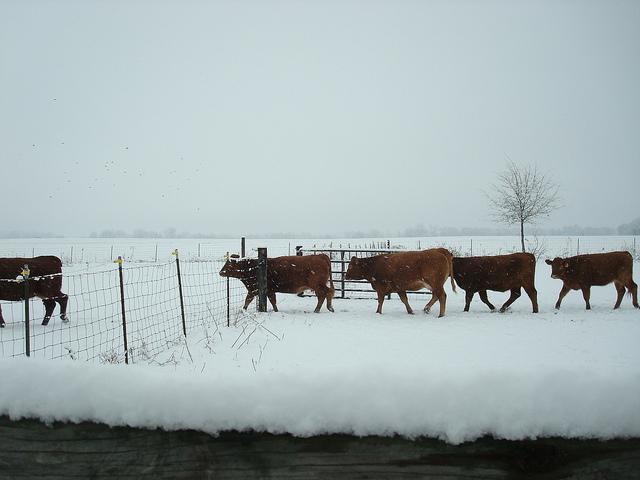How many cows are there?
Give a very brief answer. 5. How many male cows are there in the photograph?
Give a very brief answer. 5. How many cows are in the picture?
Give a very brief answer. 5. 